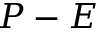<formula> <loc_0><loc_0><loc_500><loc_500>P - E</formula> 